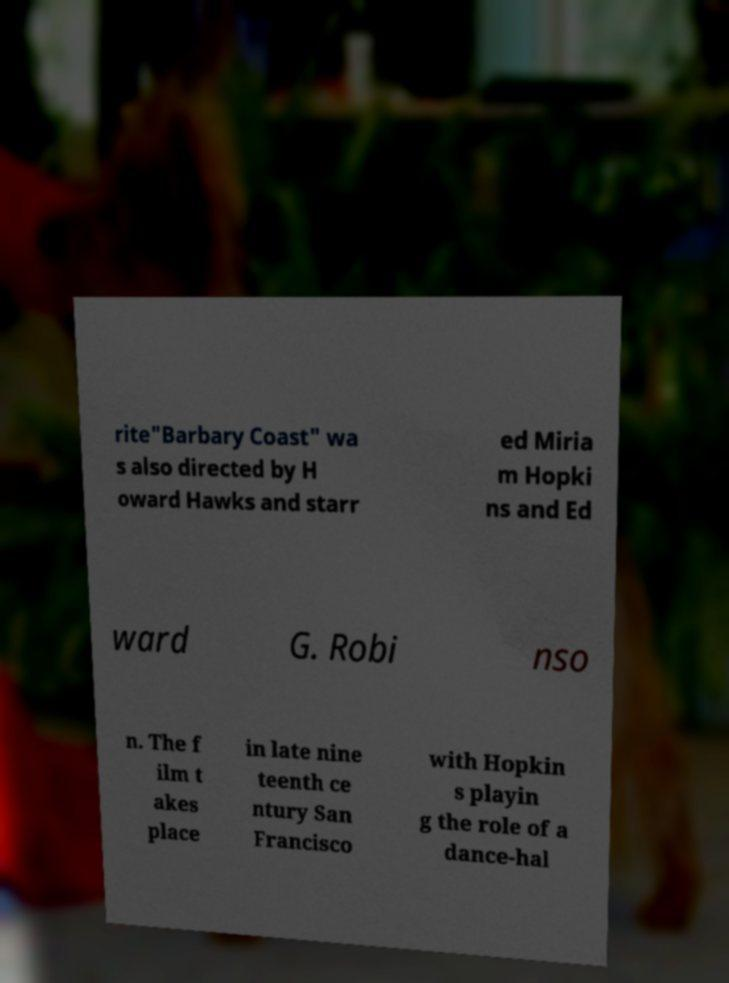Could you assist in decoding the text presented in this image and type it out clearly? rite"Barbary Coast" wa s also directed by H oward Hawks and starr ed Miria m Hopki ns and Ed ward G. Robi nso n. The f ilm t akes place in late nine teenth ce ntury San Francisco with Hopkin s playin g the role of a dance-hal 